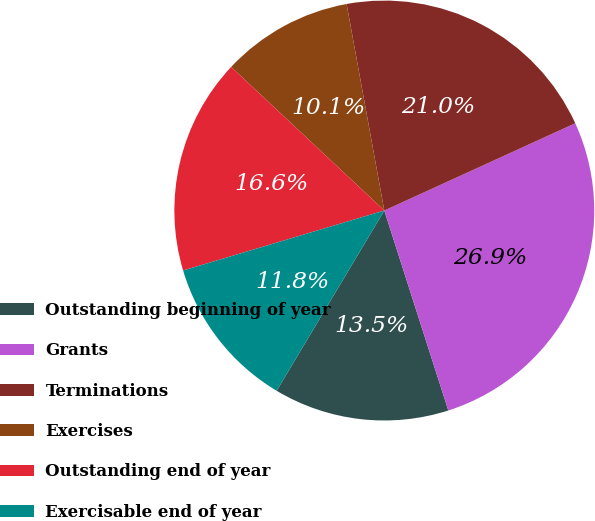Convert chart. <chart><loc_0><loc_0><loc_500><loc_500><pie_chart><fcel>Outstanding beginning of year<fcel>Grants<fcel>Terminations<fcel>Exercises<fcel>Outstanding end of year<fcel>Exercisable end of year<nl><fcel>13.5%<fcel>26.89%<fcel>21.05%<fcel>10.14%<fcel>16.6%<fcel>11.82%<nl></chart> 